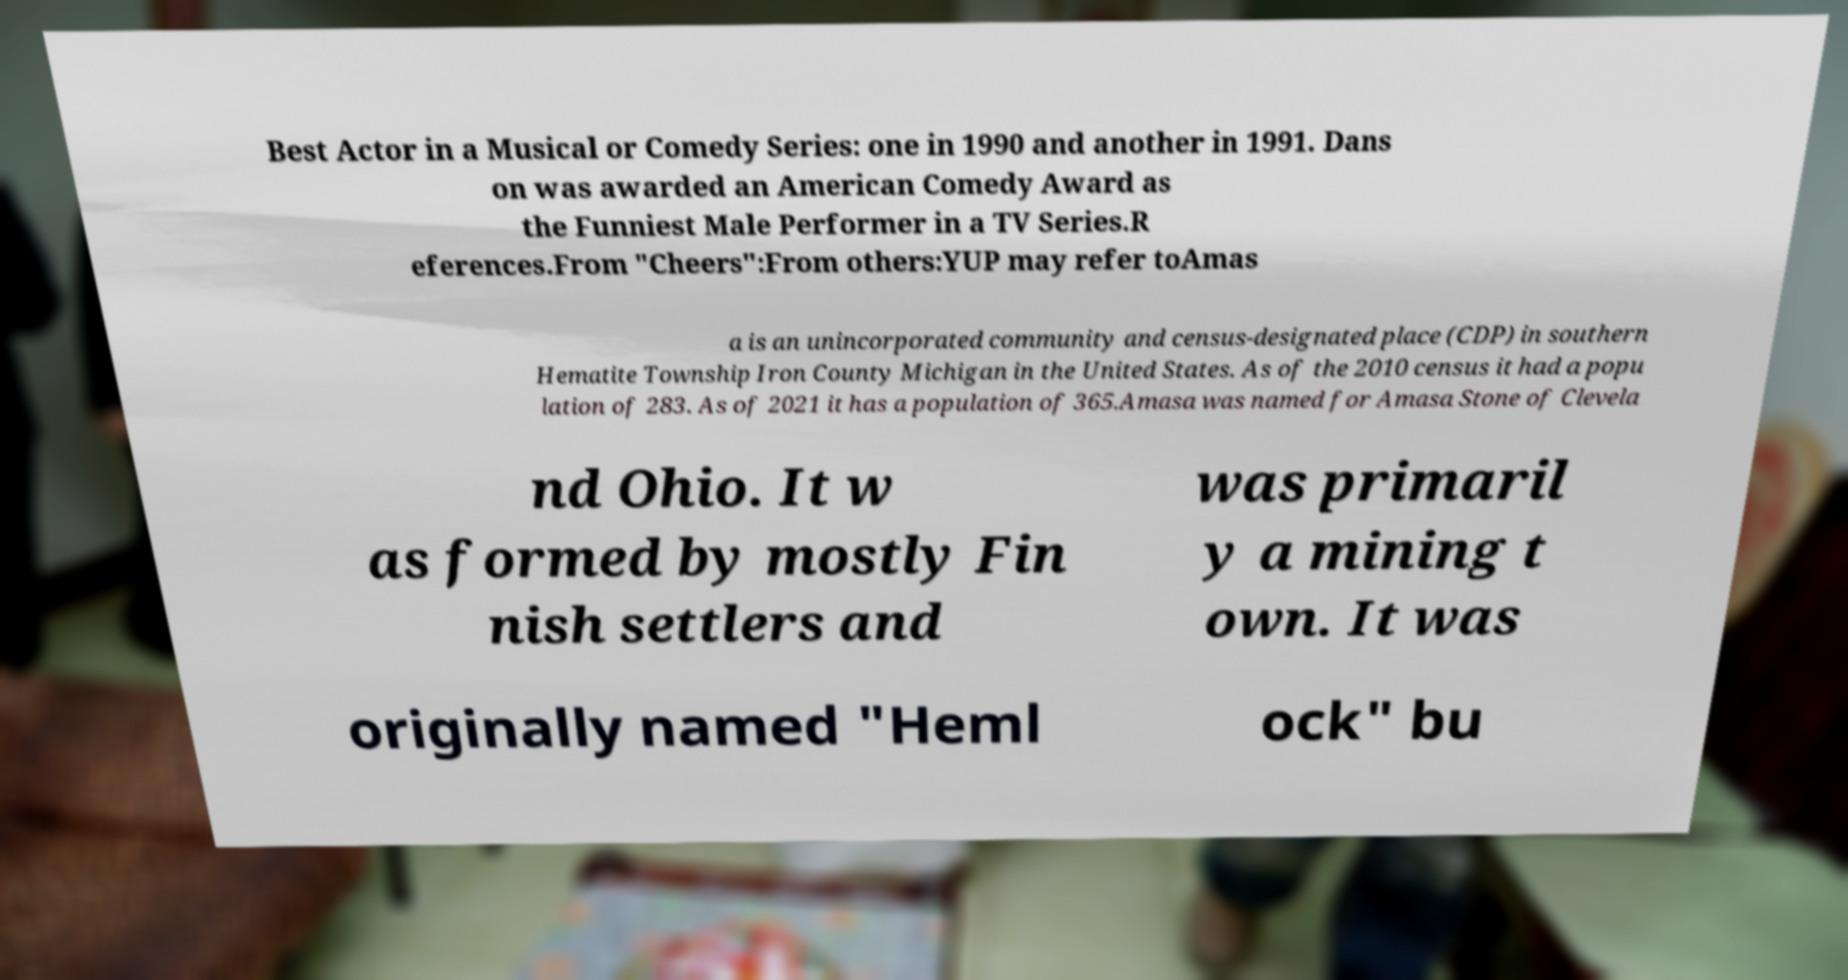Could you assist in decoding the text presented in this image and type it out clearly? Best Actor in a Musical or Comedy Series: one in 1990 and another in 1991. Dans on was awarded an American Comedy Award as the Funniest Male Performer in a TV Series.R eferences.From "Cheers":From others:YUP may refer toAmas a is an unincorporated community and census-designated place (CDP) in southern Hematite Township Iron County Michigan in the United States. As of the 2010 census it had a popu lation of 283. As of 2021 it has a population of 365.Amasa was named for Amasa Stone of Clevela nd Ohio. It w as formed by mostly Fin nish settlers and was primaril y a mining t own. It was originally named "Heml ock" bu 